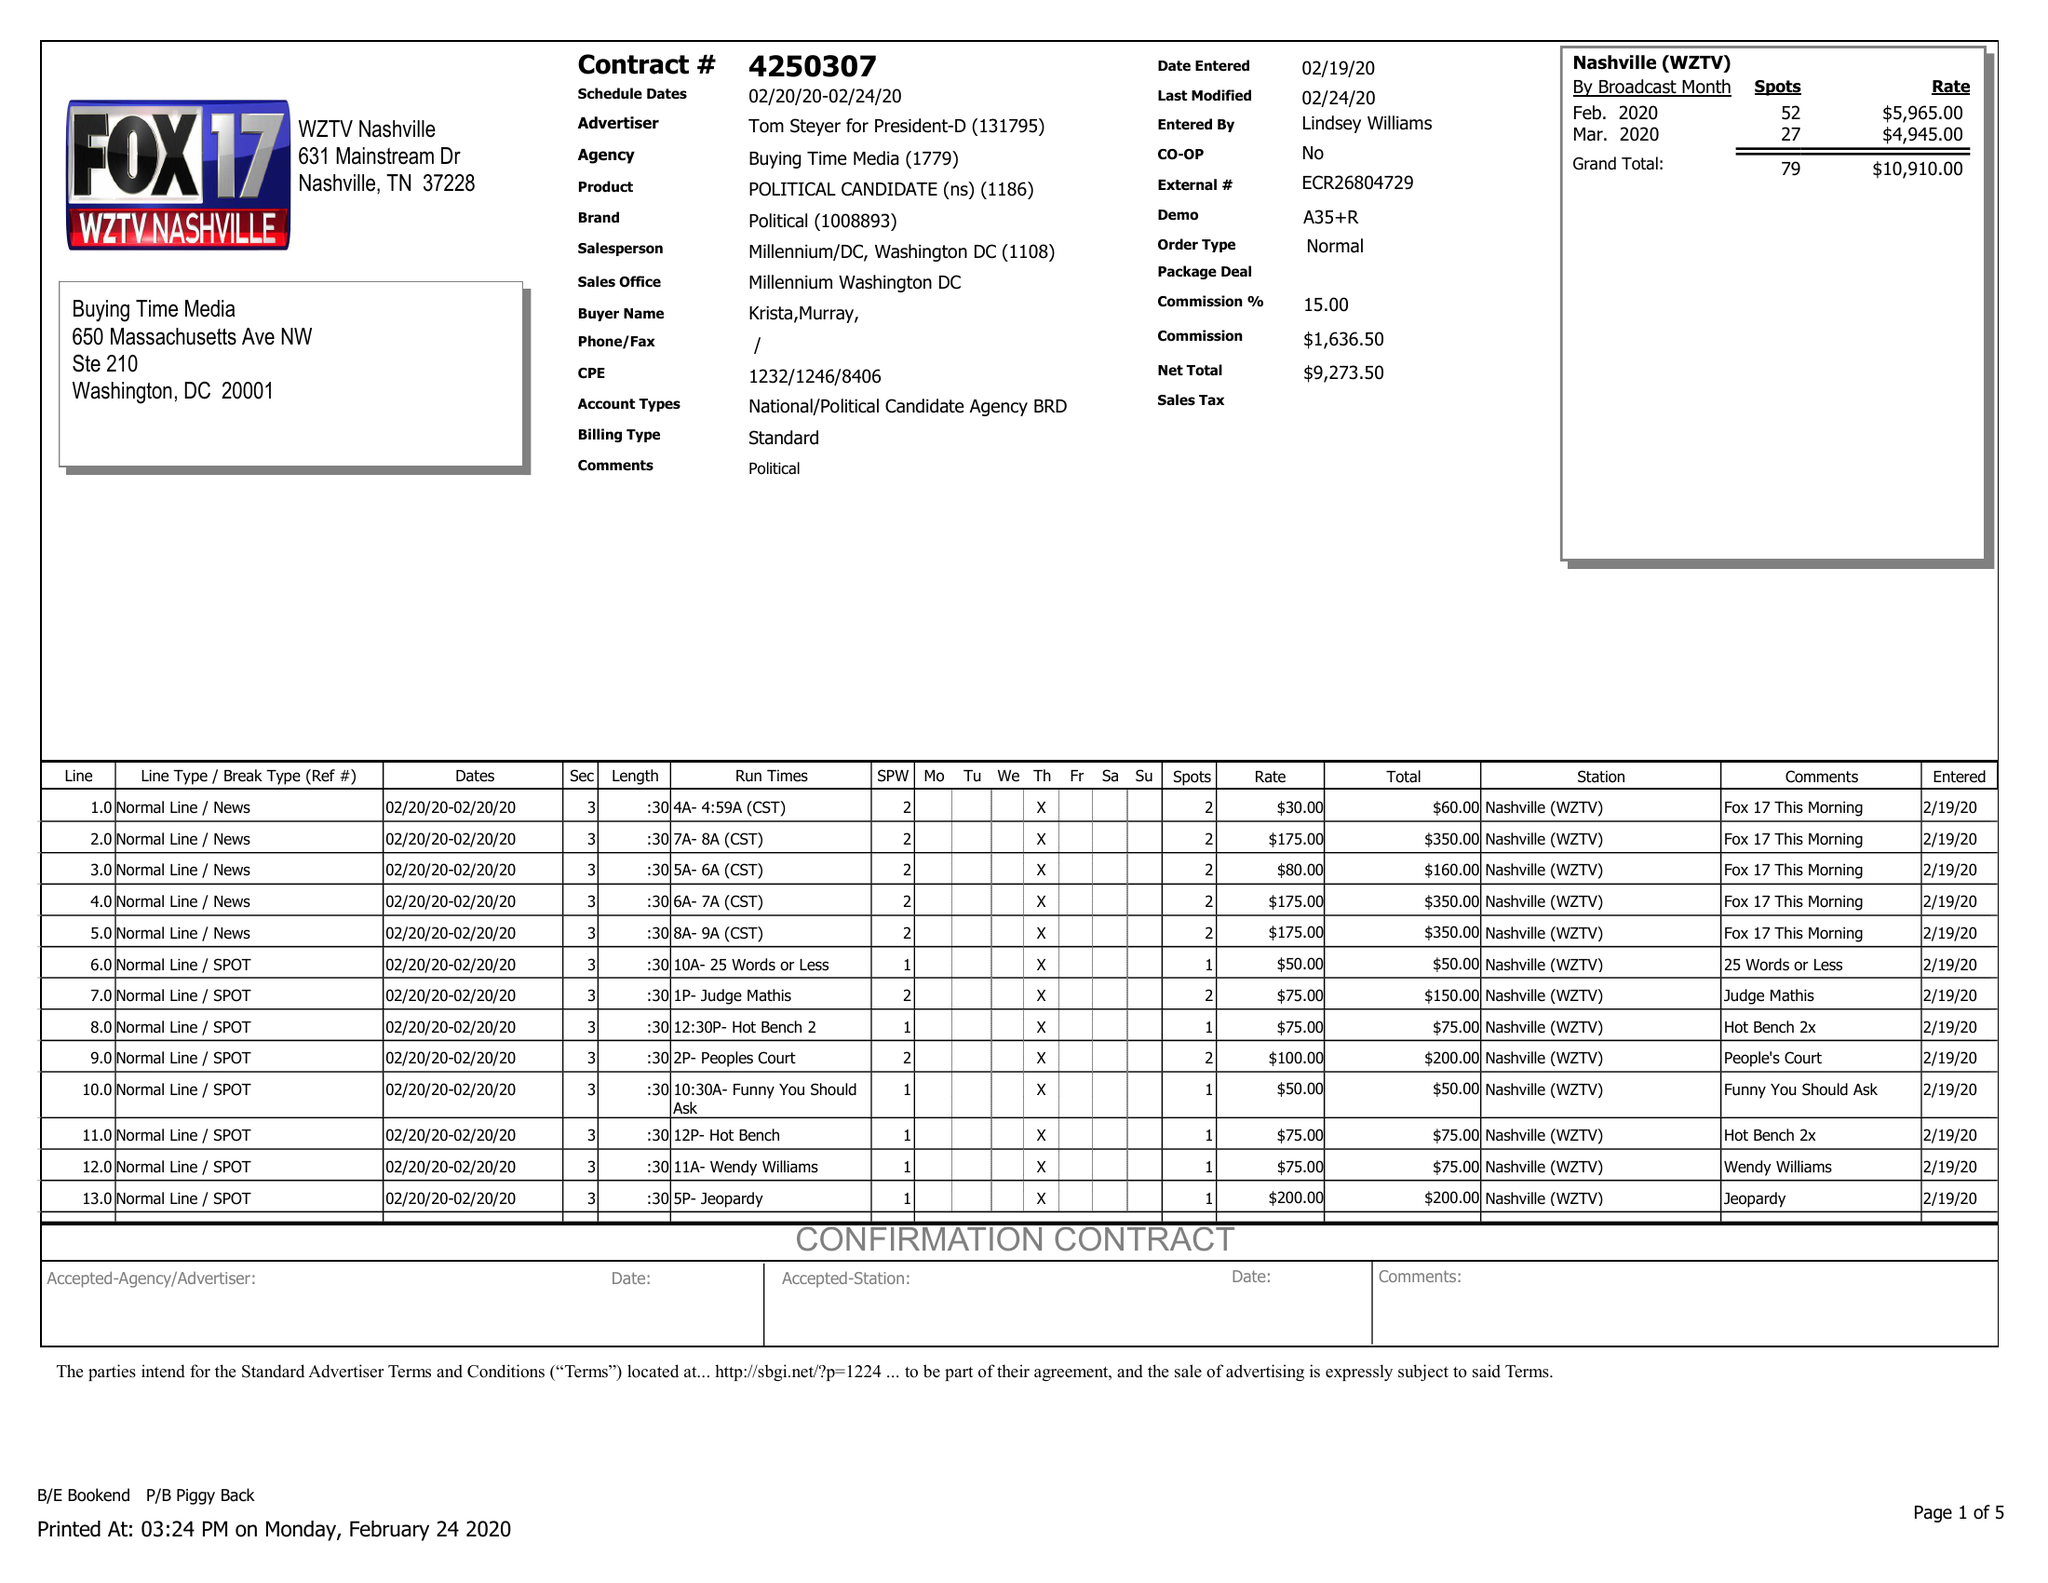What is the value for the flight_from?
Answer the question using a single word or phrase. 02/20/20 